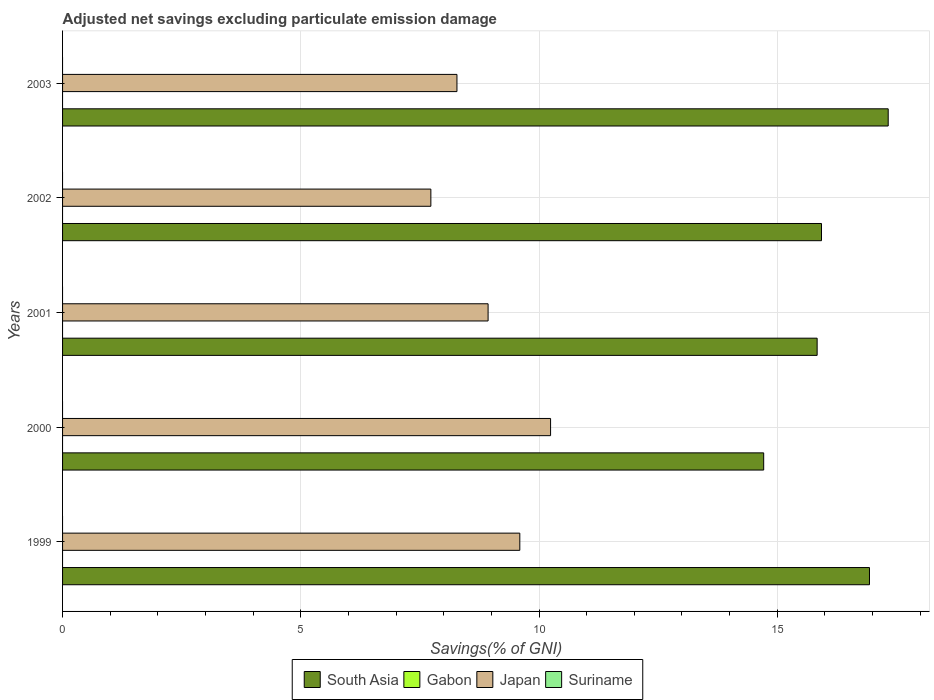How many groups of bars are there?
Keep it short and to the point. 5. Are the number of bars per tick equal to the number of legend labels?
Your answer should be very brief. No. Are the number of bars on each tick of the Y-axis equal?
Provide a short and direct response. Yes. How many bars are there on the 2nd tick from the top?
Your answer should be very brief. 2. How many bars are there on the 4th tick from the bottom?
Keep it short and to the point. 2. In how many cases, is the number of bars for a given year not equal to the number of legend labels?
Offer a terse response. 5. What is the adjusted net savings in South Asia in 2000?
Offer a terse response. 14.71. Across all years, what is the maximum adjusted net savings in Japan?
Offer a terse response. 10.24. What is the total adjusted net savings in Japan in the graph?
Give a very brief answer. 44.78. What is the difference between the adjusted net savings in South Asia in 2000 and that in 2001?
Provide a succinct answer. -1.12. What is the difference between the adjusted net savings in South Asia in 2003 and the adjusted net savings in Japan in 2002?
Your answer should be compact. 9.6. What is the average adjusted net savings in Japan per year?
Your response must be concise. 8.96. What is the ratio of the adjusted net savings in Japan in 2000 to that in 2001?
Provide a succinct answer. 1.15. What is the difference between the highest and the second highest adjusted net savings in South Asia?
Your answer should be compact. 0.39. What is the difference between the highest and the lowest adjusted net savings in South Asia?
Give a very brief answer. 2.61. In how many years, is the adjusted net savings in Gabon greater than the average adjusted net savings in Gabon taken over all years?
Your answer should be compact. 0. Is the sum of the adjusted net savings in Japan in 2000 and 2003 greater than the maximum adjusted net savings in Suriname across all years?
Offer a very short reply. Yes. Is it the case that in every year, the sum of the adjusted net savings in Suriname and adjusted net savings in Japan is greater than the sum of adjusted net savings in Gabon and adjusted net savings in South Asia?
Your answer should be compact. Yes. Is it the case that in every year, the sum of the adjusted net savings in Japan and adjusted net savings in South Asia is greater than the adjusted net savings in Suriname?
Provide a short and direct response. Yes. Are all the bars in the graph horizontal?
Your answer should be compact. Yes. What is the difference between two consecutive major ticks on the X-axis?
Give a very brief answer. 5. Does the graph contain any zero values?
Keep it short and to the point. Yes. Where does the legend appear in the graph?
Ensure brevity in your answer.  Bottom center. What is the title of the graph?
Give a very brief answer. Adjusted net savings excluding particulate emission damage. Does "West Bank and Gaza" appear as one of the legend labels in the graph?
Keep it short and to the point. No. What is the label or title of the X-axis?
Your answer should be very brief. Savings(% of GNI). What is the label or title of the Y-axis?
Offer a very short reply. Years. What is the Savings(% of GNI) in South Asia in 1999?
Ensure brevity in your answer.  16.93. What is the Savings(% of GNI) of Japan in 1999?
Your response must be concise. 9.6. What is the Savings(% of GNI) of South Asia in 2000?
Make the answer very short. 14.71. What is the Savings(% of GNI) in Japan in 2000?
Make the answer very short. 10.24. What is the Savings(% of GNI) in South Asia in 2001?
Offer a very short reply. 15.84. What is the Savings(% of GNI) in Gabon in 2001?
Ensure brevity in your answer.  0. What is the Savings(% of GNI) of Japan in 2001?
Your answer should be compact. 8.93. What is the Savings(% of GNI) in Suriname in 2001?
Give a very brief answer. 0. What is the Savings(% of GNI) of South Asia in 2002?
Give a very brief answer. 15.93. What is the Savings(% of GNI) of Japan in 2002?
Your answer should be very brief. 7.73. What is the Savings(% of GNI) of South Asia in 2003?
Provide a succinct answer. 17.33. What is the Savings(% of GNI) in Gabon in 2003?
Give a very brief answer. 0. What is the Savings(% of GNI) of Japan in 2003?
Your response must be concise. 8.28. Across all years, what is the maximum Savings(% of GNI) in South Asia?
Your answer should be very brief. 17.33. Across all years, what is the maximum Savings(% of GNI) in Japan?
Offer a very short reply. 10.24. Across all years, what is the minimum Savings(% of GNI) of South Asia?
Offer a terse response. 14.71. Across all years, what is the minimum Savings(% of GNI) of Japan?
Offer a very short reply. 7.73. What is the total Savings(% of GNI) of South Asia in the graph?
Your answer should be very brief. 80.74. What is the total Savings(% of GNI) of Japan in the graph?
Your answer should be compact. 44.78. What is the total Savings(% of GNI) of Suriname in the graph?
Your answer should be very brief. 0. What is the difference between the Savings(% of GNI) in South Asia in 1999 and that in 2000?
Give a very brief answer. 2.22. What is the difference between the Savings(% of GNI) in Japan in 1999 and that in 2000?
Ensure brevity in your answer.  -0.65. What is the difference between the Savings(% of GNI) in South Asia in 1999 and that in 2001?
Offer a very short reply. 1.1. What is the difference between the Savings(% of GNI) of Japan in 1999 and that in 2001?
Offer a terse response. 0.67. What is the difference between the Savings(% of GNI) in Japan in 1999 and that in 2002?
Make the answer very short. 1.87. What is the difference between the Savings(% of GNI) in South Asia in 1999 and that in 2003?
Make the answer very short. -0.39. What is the difference between the Savings(% of GNI) in Japan in 1999 and that in 2003?
Offer a very short reply. 1.32. What is the difference between the Savings(% of GNI) in South Asia in 2000 and that in 2001?
Your answer should be very brief. -1.12. What is the difference between the Savings(% of GNI) of Japan in 2000 and that in 2001?
Keep it short and to the point. 1.31. What is the difference between the Savings(% of GNI) of South Asia in 2000 and that in 2002?
Your response must be concise. -1.21. What is the difference between the Savings(% of GNI) of Japan in 2000 and that in 2002?
Make the answer very short. 2.51. What is the difference between the Savings(% of GNI) of South Asia in 2000 and that in 2003?
Provide a succinct answer. -2.61. What is the difference between the Savings(% of GNI) of Japan in 2000 and that in 2003?
Your answer should be compact. 1.97. What is the difference between the Savings(% of GNI) in South Asia in 2001 and that in 2002?
Give a very brief answer. -0.09. What is the difference between the Savings(% of GNI) in Japan in 2001 and that in 2002?
Ensure brevity in your answer.  1.2. What is the difference between the Savings(% of GNI) of South Asia in 2001 and that in 2003?
Your answer should be compact. -1.49. What is the difference between the Savings(% of GNI) of Japan in 2001 and that in 2003?
Offer a terse response. 0.65. What is the difference between the Savings(% of GNI) of South Asia in 2002 and that in 2003?
Provide a short and direct response. -1.4. What is the difference between the Savings(% of GNI) of Japan in 2002 and that in 2003?
Your response must be concise. -0.55. What is the difference between the Savings(% of GNI) of South Asia in 1999 and the Savings(% of GNI) of Japan in 2000?
Offer a very short reply. 6.69. What is the difference between the Savings(% of GNI) of South Asia in 1999 and the Savings(% of GNI) of Japan in 2001?
Ensure brevity in your answer.  8. What is the difference between the Savings(% of GNI) of South Asia in 1999 and the Savings(% of GNI) of Japan in 2002?
Give a very brief answer. 9.21. What is the difference between the Savings(% of GNI) of South Asia in 1999 and the Savings(% of GNI) of Japan in 2003?
Keep it short and to the point. 8.66. What is the difference between the Savings(% of GNI) of South Asia in 2000 and the Savings(% of GNI) of Japan in 2001?
Your response must be concise. 5.78. What is the difference between the Savings(% of GNI) of South Asia in 2000 and the Savings(% of GNI) of Japan in 2002?
Ensure brevity in your answer.  6.99. What is the difference between the Savings(% of GNI) in South Asia in 2000 and the Savings(% of GNI) in Japan in 2003?
Make the answer very short. 6.44. What is the difference between the Savings(% of GNI) in South Asia in 2001 and the Savings(% of GNI) in Japan in 2002?
Make the answer very short. 8.11. What is the difference between the Savings(% of GNI) in South Asia in 2001 and the Savings(% of GNI) in Japan in 2003?
Give a very brief answer. 7.56. What is the difference between the Savings(% of GNI) in South Asia in 2002 and the Savings(% of GNI) in Japan in 2003?
Keep it short and to the point. 7.65. What is the average Savings(% of GNI) in South Asia per year?
Provide a succinct answer. 16.15. What is the average Savings(% of GNI) in Japan per year?
Give a very brief answer. 8.96. In the year 1999, what is the difference between the Savings(% of GNI) of South Asia and Savings(% of GNI) of Japan?
Offer a very short reply. 7.34. In the year 2000, what is the difference between the Savings(% of GNI) in South Asia and Savings(% of GNI) in Japan?
Provide a short and direct response. 4.47. In the year 2001, what is the difference between the Savings(% of GNI) in South Asia and Savings(% of GNI) in Japan?
Offer a very short reply. 6.91. In the year 2002, what is the difference between the Savings(% of GNI) in South Asia and Savings(% of GNI) in Japan?
Your answer should be compact. 8.2. In the year 2003, what is the difference between the Savings(% of GNI) of South Asia and Savings(% of GNI) of Japan?
Ensure brevity in your answer.  9.05. What is the ratio of the Savings(% of GNI) in South Asia in 1999 to that in 2000?
Offer a terse response. 1.15. What is the ratio of the Savings(% of GNI) in Japan in 1999 to that in 2000?
Keep it short and to the point. 0.94. What is the ratio of the Savings(% of GNI) of South Asia in 1999 to that in 2001?
Make the answer very short. 1.07. What is the ratio of the Savings(% of GNI) in Japan in 1999 to that in 2001?
Your answer should be very brief. 1.07. What is the ratio of the Savings(% of GNI) in South Asia in 1999 to that in 2002?
Ensure brevity in your answer.  1.06. What is the ratio of the Savings(% of GNI) in Japan in 1999 to that in 2002?
Your response must be concise. 1.24. What is the ratio of the Savings(% of GNI) in South Asia in 1999 to that in 2003?
Your answer should be very brief. 0.98. What is the ratio of the Savings(% of GNI) in Japan in 1999 to that in 2003?
Offer a terse response. 1.16. What is the ratio of the Savings(% of GNI) in South Asia in 2000 to that in 2001?
Give a very brief answer. 0.93. What is the ratio of the Savings(% of GNI) of Japan in 2000 to that in 2001?
Your answer should be compact. 1.15. What is the ratio of the Savings(% of GNI) in South Asia in 2000 to that in 2002?
Offer a very short reply. 0.92. What is the ratio of the Savings(% of GNI) of Japan in 2000 to that in 2002?
Give a very brief answer. 1.33. What is the ratio of the Savings(% of GNI) of South Asia in 2000 to that in 2003?
Give a very brief answer. 0.85. What is the ratio of the Savings(% of GNI) of Japan in 2000 to that in 2003?
Make the answer very short. 1.24. What is the ratio of the Savings(% of GNI) in Japan in 2001 to that in 2002?
Give a very brief answer. 1.16. What is the ratio of the Savings(% of GNI) in South Asia in 2001 to that in 2003?
Make the answer very short. 0.91. What is the ratio of the Savings(% of GNI) of Japan in 2001 to that in 2003?
Give a very brief answer. 1.08. What is the ratio of the Savings(% of GNI) in South Asia in 2002 to that in 2003?
Give a very brief answer. 0.92. What is the ratio of the Savings(% of GNI) of Japan in 2002 to that in 2003?
Provide a succinct answer. 0.93. What is the difference between the highest and the second highest Savings(% of GNI) in South Asia?
Make the answer very short. 0.39. What is the difference between the highest and the second highest Savings(% of GNI) of Japan?
Your answer should be compact. 0.65. What is the difference between the highest and the lowest Savings(% of GNI) in South Asia?
Offer a terse response. 2.61. What is the difference between the highest and the lowest Savings(% of GNI) of Japan?
Ensure brevity in your answer.  2.51. 